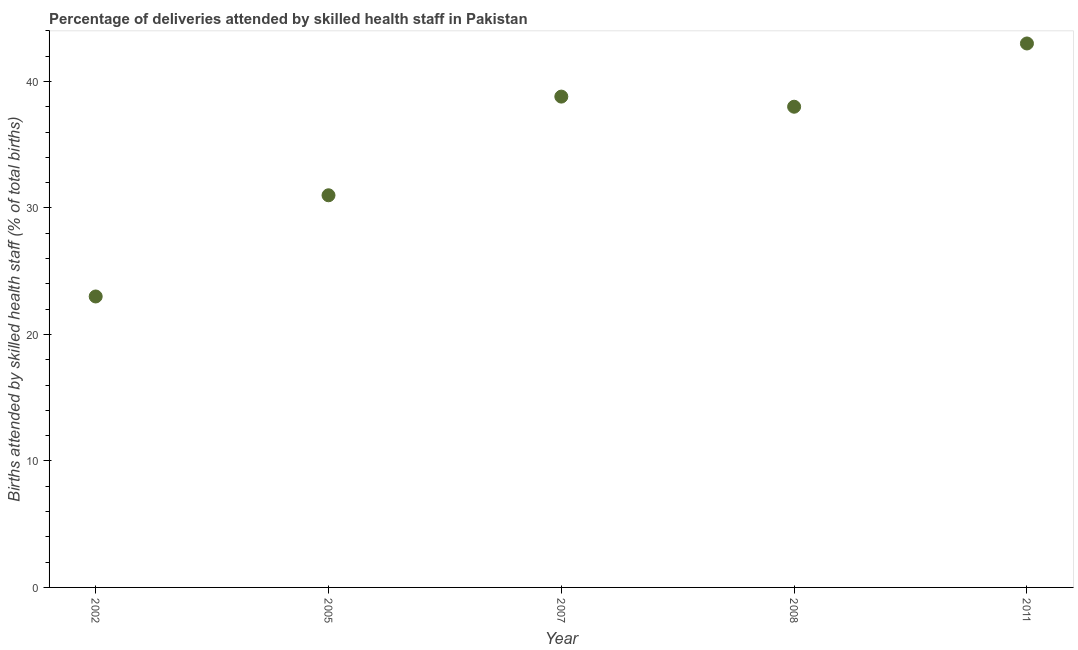What is the number of births attended by skilled health staff in 2011?
Keep it short and to the point. 43. In which year was the number of births attended by skilled health staff maximum?
Provide a succinct answer. 2011. In which year was the number of births attended by skilled health staff minimum?
Your response must be concise. 2002. What is the sum of the number of births attended by skilled health staff?
Offer a terse response. 173.8. What is the difference between the number of births attended by skilled health staff in 2005 and 2008?
Offer a terse response. -7. What is the average number of births attended by skilled health staff per year?
Your answer should be compact. 34.76. What is the median number of births attended by skilled health staff?
Your answer should be very brief. 38. Do a majority of the years between 2002 and 2007 (inclusive) have number of births attended by skilled health staff greater than 32 %?
Ensure brevity in your answer.  No. What is the ratio of the number of births attended by skilled health staff in 2002 to that in 2011?
Your answer should be compact. 0.53. Is the difference between the number of births attended by skilled health staff in 2008 and 2011 greater than the difference between any two years?
Provide a short and direct response. No. What is the difference between the highest and the second highest number of births attended by skilled health staff?
Give a very brief answer. 4.2. What is the difference between the highest and the lowest number of births attended by skilled health staff?
Keep it short and to the point. 20. What is the difference between two consecutive major ticks on the Y-axis?
Offer a terse response. 10. What is the title of the graph?
Your answer should be compact. Percentage of deliveries attended by skilled health staff in Pakistan. What is the label or title of the Y-axis?
Keep it short and to the point. Births attended by skilled health staff (% of total births). What is the Births attended by skilled health staff (% of total births) in 2002?
Your response must be concise. 23. What is the Births attended by skilled health staff (% of total births) in 2007?
Provide a succinct answer. 38.8. What is the Births attended by skilled health staff (% of total births) in 2011?
Your answer should be compact. 43. What is the difference between the Births attended by skilled health staff (% of total births) in 2002 and 2007?
Give a very brief answer. -15.8. What is the ratio of the Births attended by skilled health staff (% of total births) in 2002 to that in 2005?
Ensure brevity in your answer.  0.74. What is the ratio of the Births attended by skilled health staff (% of total births) in 2002 to that in 2007?
Your response must be concise. 0.59. What is the ratio of the Births attended by skilled health staff (% of total births) in 2002 to that in 2008?
Ensure brevity in your answer.  0.6. What is the ratio of the Births attended by skilled health staff (% of total births) in 2002 to that in 2011?
Offer a very short reply. 0.54. What is the ratio of the Births attended by skilled health staff (% of total births) in 2005 to that in 2007?
Provide a succinct answer. 0.8. What is the ratio of the Births attended by skilled health staff (% of total births) in 2005 to that in 2008?
Your answer should be compact. 0.82. What is the ratio of the Births attended by skilled health staff (% of total births) in 2005 to that in 2011?
Offer a very short reply. 0.72. What is the ratio of the Births attended by skilled health staff (% of total births) in 2007 to that in 2008?
Offer a terse response. 1.02. What is the ratio of the Births attended by skilled health staff (% of total births) in 2007 to that in 2011?
Offer a very short reply. 0.9. What is the ratio of the Births attended by skilled health staff (% of total births) in 2008 to that in 2011?
Keep it short and to the point. 0.88. 